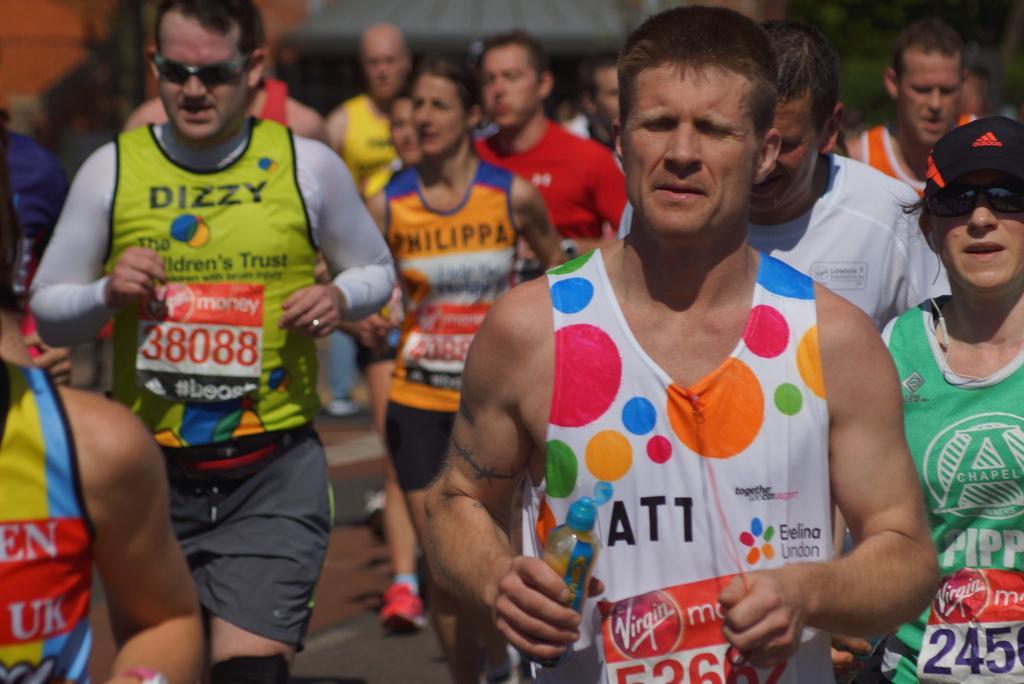Please provide a concise description of this image. In this image we can see people. A person is holding a bottle. Background it is blur. 